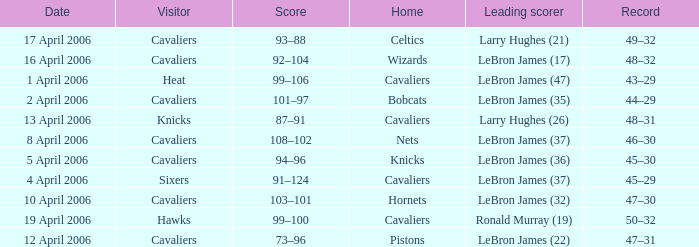Help me parse the entirety of this table. {'header': ['Date', 'Visitor', 'Score', 'Home', 'Leading scorer', 'Record'], 'rows': [['17 April 2006', 'Cavaliers', '93–88', 'Celtics', 'Larry Hughes (21)', '49–32'], ['16 April 2006', 'Cavaliers', '92–104', 'Wizards', 'LeBron James (17)', '48–32'], ['1 April 2006', 'Heat', '99–106', 'Cavaliers', 'LeBron James (47)', '43–29'], ['2 April 2006', 'Cavaliers', '101–97', 'Bobcats', 'LeBron James (35)', '44–29'], ['13 April 2006', 'Knicks', '87–91', 'Cavaliers', 'Larry Hughes (26)', '48–31'], ['8 April 2006', 'Cavaliers', '108–102', 'Nets', 'LeBron James (37)', '46–30'], ['5 April 2006', 'Cavaliers', '94–96', 'Knicks', 'LeBron James (36)', '45–30'], ['4 April 2006', 'Sixers', '91–124', 'Cavaliers', 'LeBron James (37)', '45–29'], ['10 April 2006', 'Cavaliers', '103–101', 'Hornets', 'LeBron James (32)', '47–30'], ['19 April 2006', 'Hawks', '99–100', 'Cavaliers', 'Ronald Murray (19)', '50–32'], ['12 April 2006', 'Cavaliers', '73–96', 'Pistons', 'LeBron James (22)', '47–31']]} What day was the game that had the Cavaliers as visiting team and the Knicks as the home team? 5 April 2006. 